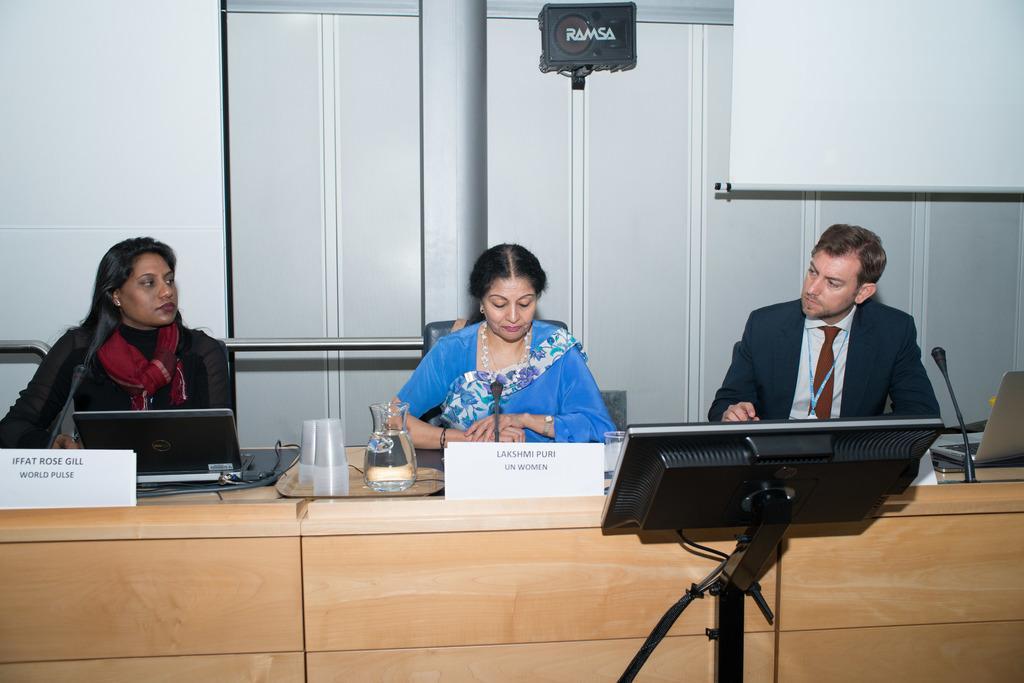Describe this image in one or two sentences. In this image we can see people sitting on chairs. There is a table on which there are laptops, glasses, mics and other objects. In the foreground of the image there is a screen with a stand. In the background of the image there is wall. There is a white color screen. 